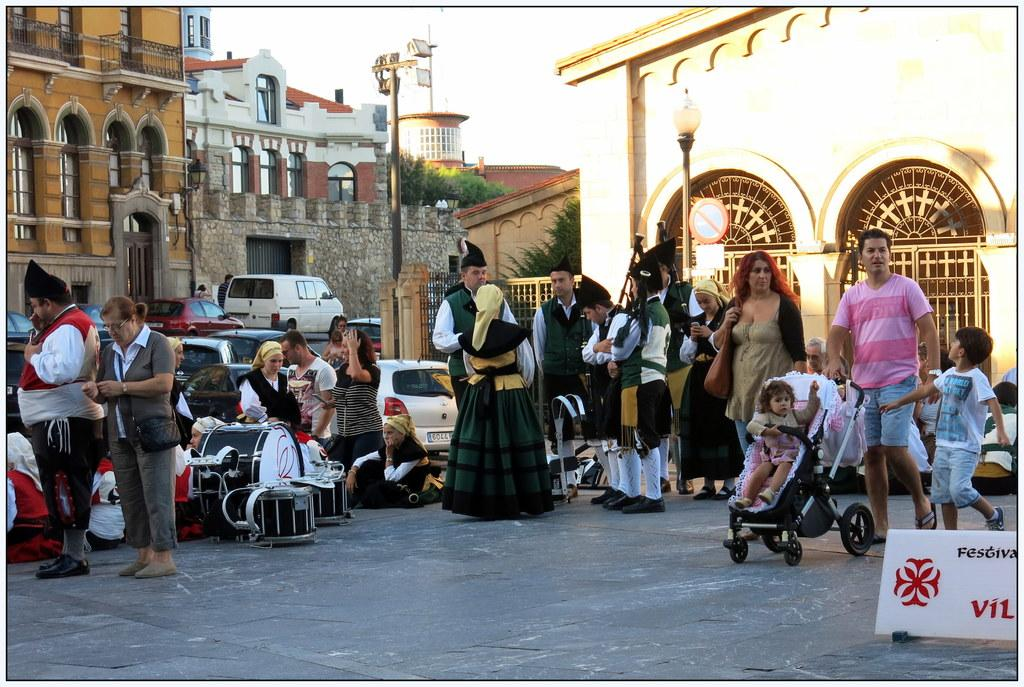How many people are in the image? There are many people in the image. What are the people wearing? The people are wearing different costumes. Where are the people standing? The people are standing on a road. What type of waste can be seen on the road in the image? There is no waste visible on the road in the image. What is the people's reaction to the hen in the image? There is no hen present in the image. 